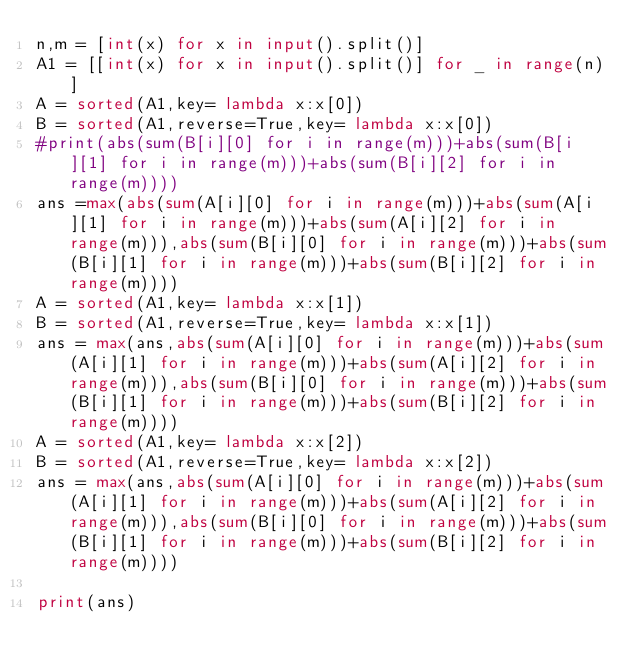Convert code to text. <code><loc_0><loc_0><loc_500><loc_500><_Python_>n,m = [int(x) for x in input().split()]
A1 = [[int(x) for x in input().split()] for _ in range(n)]
A = sorted(A1,key= lambda x:x[0])
B = sorted(A1,reverse=True,key= lambda x:x[0])
#print(abs(sum(B[i][0] for i in range(m)))+abs(sum(B[i][1] for i in range(m)))+abs(sum(B[i][2] for i in range(m))))
ans =max(abs(sum(A[i][0] for i in range(m)))+abs(sum(A[i][1] for i in range(m)))+abs(sum(A[i][2] for i in range(m))),abs(sum(B[i][0] for i in range(m)))+abs(sum(B[i][1] for i in range(m)))+abs(sum(B[i][2] for i in range(m))))
A = sorted(A1,key= lambda x:x[1])
B = sorted(A1,reverse=True,key= lambda x:x[1])
ans = max(ans,abs(sum(A[i][0] for i in range(m)))+abs(sum(A[i][1] for i in range(m)))+abs(sum(A[i][2] for i in range(m))),abs(sum(B[i][0] for i in range(m)))+abs(sum(B[i][1] for i in range(m)))+abs(sum(B[i][2] for i in range(m))))
A = sorted(A1,key= lambda x:x[2])
B = sorted(A1,reverse=True,key= lambda x:x[2])
ans = max(ans,abs(sum(A[i][0] for i in range(m)))+abs(sum(A[i][1] for i in range(m)))+abs(sum(A[i][2] for i in range(m))),abs(sum(B[i][0] for i in range(m)))+abs(sum(B[i][1] for i in range(m)))+abs(sum(B[i][2] for i in range(m))))

print(ans)</code> 